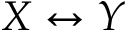<formula> <loc_0><loc_0><loc_500><loc_500>X \leftrightarrow Y</formula> 